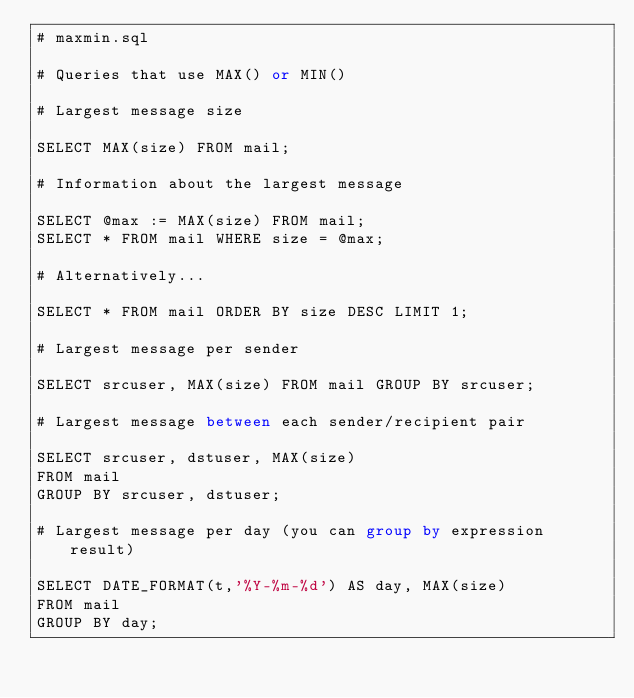<code> <loc_0><loc_0><loc_500><loc_500><_SQL_># maxmin.sql

# Queries that use MAX() or MIN()

# Largest message size

SELECT MAX(size) FROM mail;

# Information about the largest message

SELECT @max := MAX(size) FROM mail;
SELECT * FROM mail WHERE size = @max;

# Alternatively...

SELECT * FROM mail ORDER BY size DESC LIMIT 1;

# Largest message per sender

SELECT srcuser, MAX(size) FROM mail GROUP BY srcuser;

# Largest message between each sender/recipient pair

SELECT srcuser, dstuser, MAX(size)
FROM mail
GROUP BY srcuser, dstuser;

# Largest message per day (you can group by expression result)

SELECT DATE_FORMAT(t,'%Y-%m-%d') AS day, MAX(size)
FROM mail
GROUP BY day;
</code> 